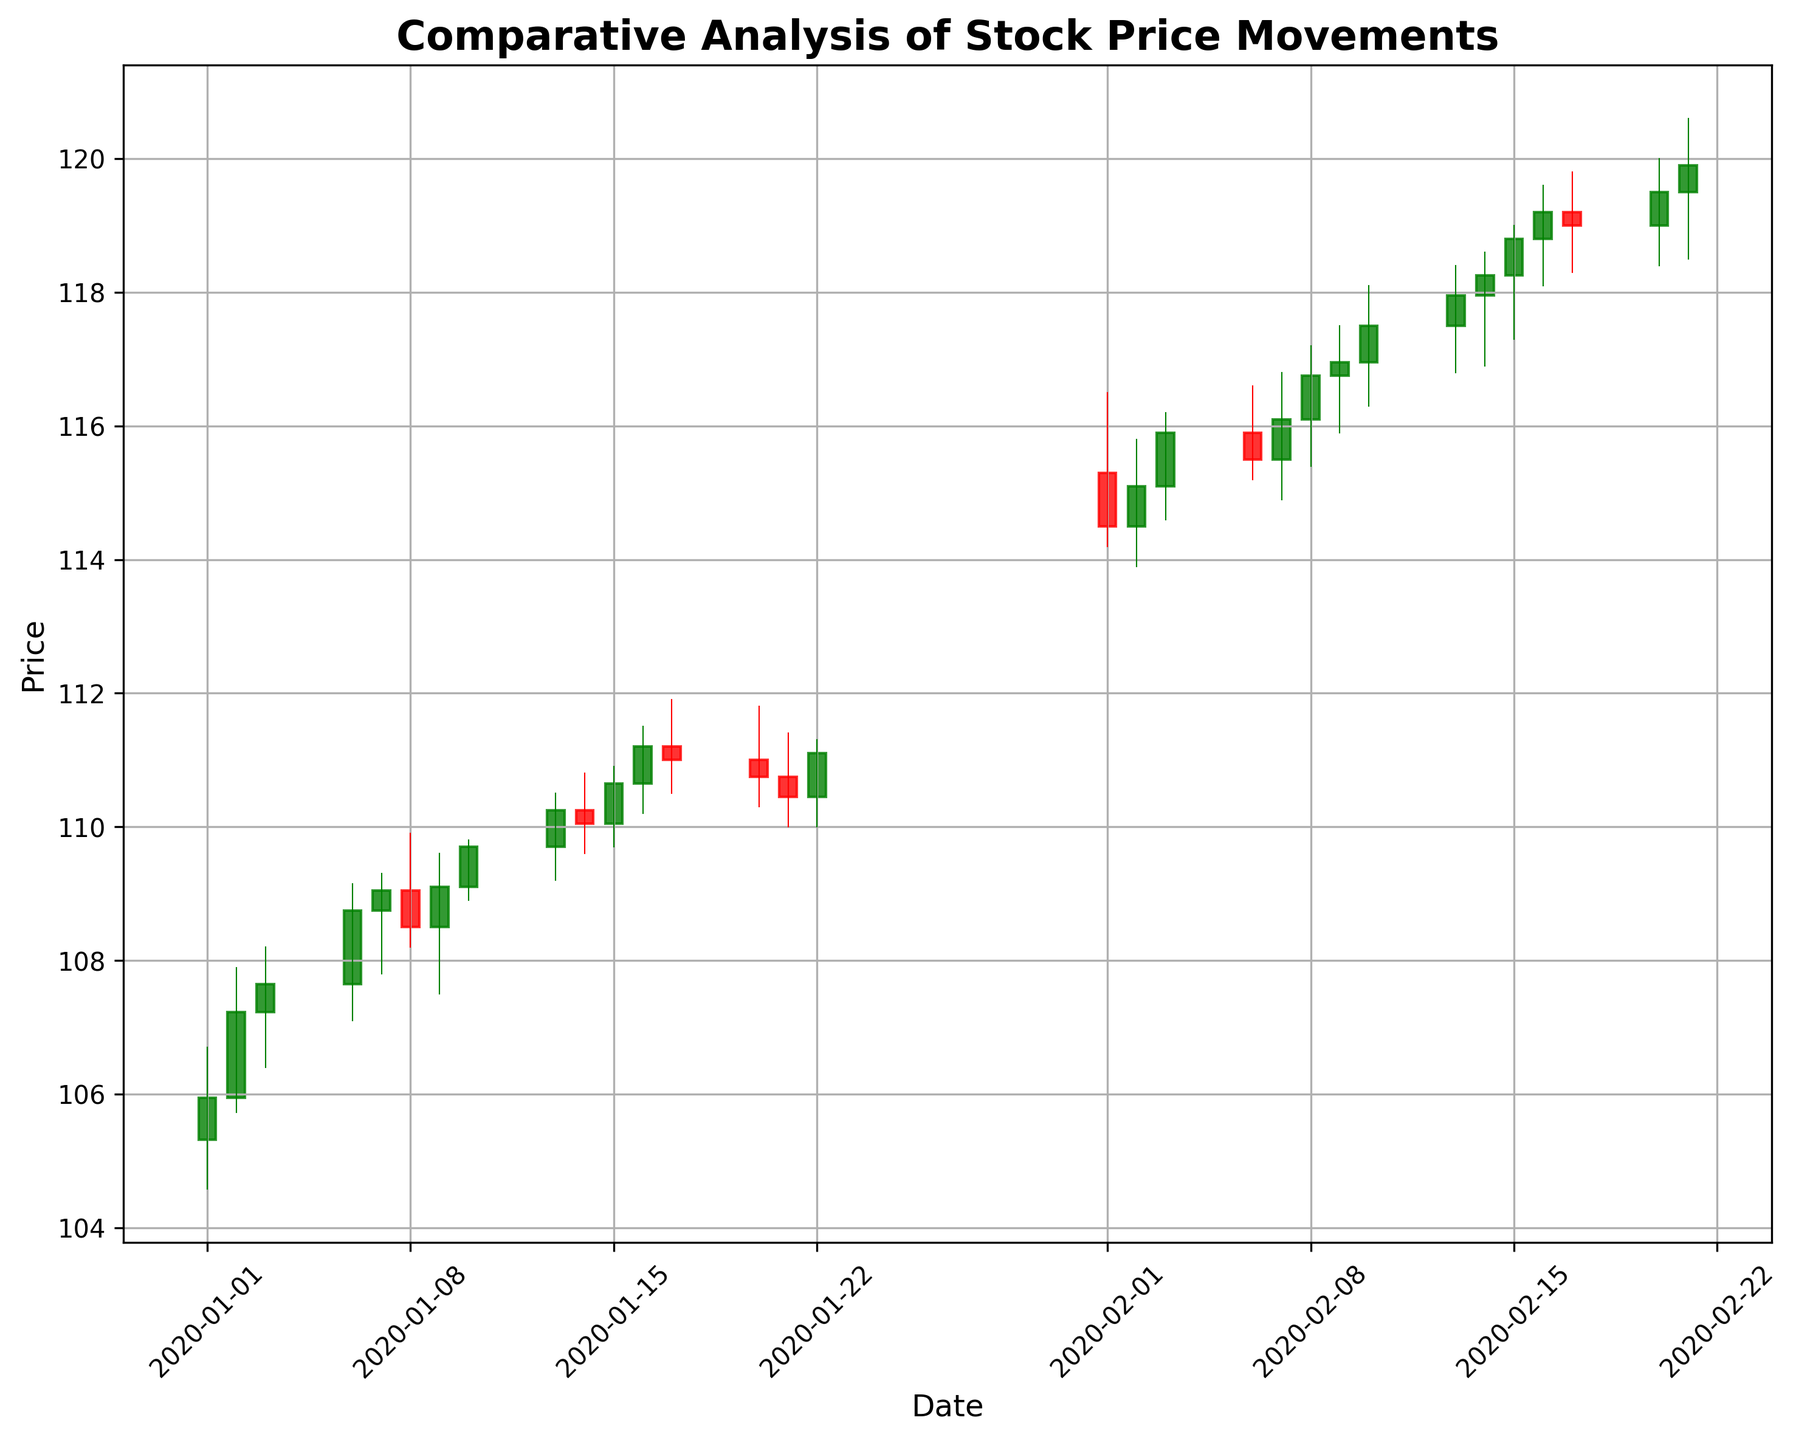what overall trend do you observe in the stock prices from January to February? To determine the overall trend, observe the candlestick colors and their progression over the period. Most candles from mid-January to February are green, indicating an overall upward trend in stock prices.
Answer: Upward Comparing the first and last candle in the chart, which is higher? The height is determined by the closing prices. The last day's candle (February 21) shows a higher closing price compared to the first day (January 1).
Answer: Last candle On which date did the stock price see the highest close? Observe and compare the height of the ‘close’ segment of green candles. The highest close seems to occur on February 16, 2020.
Answer: February 16, 2020 What is the difference between the closing price on January 2 and January 3? The closing price on January 2 is 107.23 and on January 3 is 107.65. Subtract the former from the latter: 107.65 - 107.23.
Answer: 0.42 Which date had the largest trading volume, and what is the volume? Check the labels or visual height of the candlesticks associated with volume (if present in the chart). From the data, the largest volume is 1,900,000 on February 15.
Answer: February 15, 1,900,000 Comparing the candlesticks on January 8 and January 20, which date had a greater price fluctuation? Price fluctuation is determined by the difference between the high and low values of each candle. Compare (109.90 - 108.20) for January 8 and (111.80 - 110.30) for January 20. January 20 has a greater fluctuation: 1.50.
Answer: January 20 Between February 8 and February 13, which day saw the largest increase in closing price? Analyze the closing prices for each date and find the largest increase: February 8 (116.75), February 9 (116.95), February 10 (117.50), February 13 (117.95). The largest increase happens between February 8 and February 9: 116.95 - 116.75.
Answer: February 8-9 Calculate the average closing price for January. Add all closing prices for January and divide by the number of days. (105.95 + 107.23 + 107.65 + 108.75 + 109.05 + 108.50 + 109.10 + 109.70 + 110.25 + 110.05 + 110.65 + 111.20 + 111.00 + 110.75 + 110.45 + 111.10) / 16 = 109.34.
Answer: 109.34 Which dates have at least a $1 difference between the opening and closing prices? Look for candlesticks where the difference between the body (Open and Close) is at least $1. Dates like January 7 (108.75 - 109.05) and February 8 (116.10 - 116.75) meet this criterion.
Answer: January 7, February 8 How did the stock price react immediately after a regulatory change on February 1? By observing the candlestick immediately after February 1, we see the Red candle indicating a slight fall in the closing price on February 1, but an immediate recovery on the following days.
Answer: Immediate fall, then recovery 